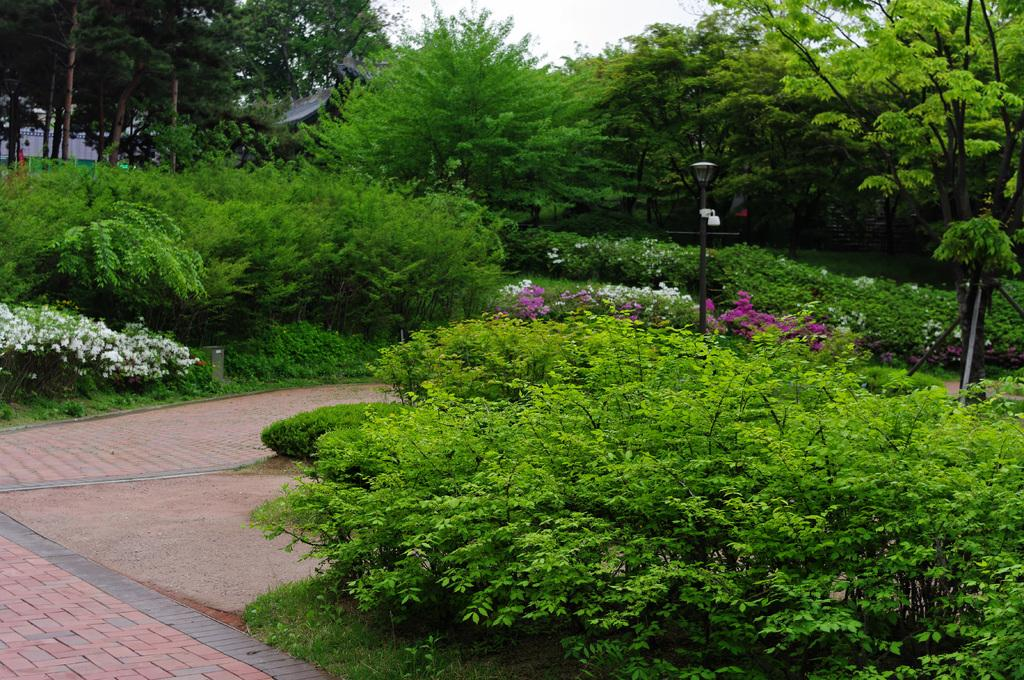What type of vegetation can be seen in the image? There are plants, flowers, and grass in the image. What other objects can be seen in the image? There are trees, a street lamp, and a building in the background of the image. What is visible at the top of the image? The sky is visible at the top of the image. What type of knowledge is being sold at the market in the image? There is no market present in the image, so it is not possible to determine what type of knowledge might be sold. 